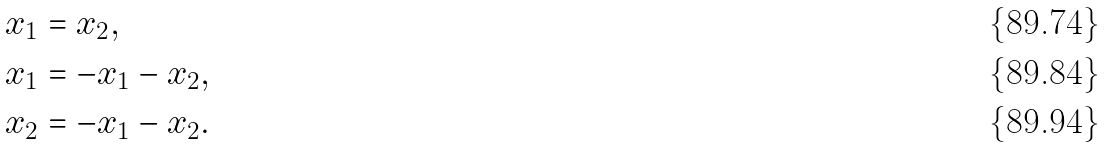<formula> <loc_0><loc_0><loc_500><loc_500>x _ { 1 } & = x _ { 2 } , \\ x _ { 1 } & = - x _ { 1 } - x _ { 2 } , \\ x _ { 2 } & = - x _ { 1 } - x _ { 2 } .</formula> 